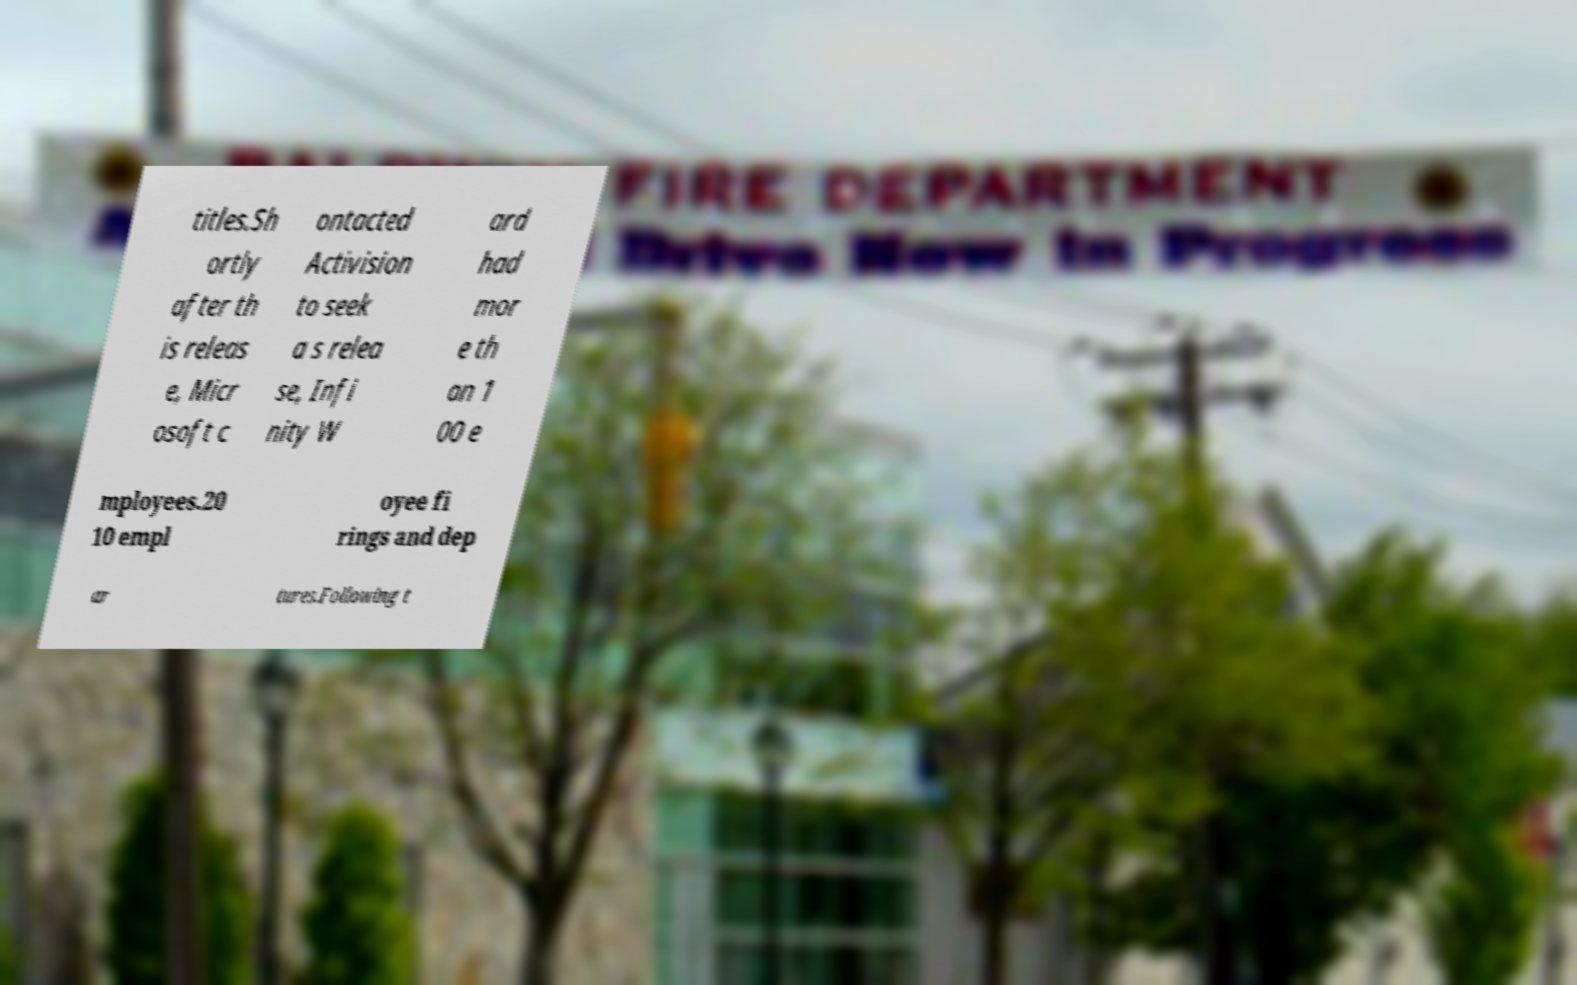Can you accurately transcribe the text from the provided image for me? titles.Sh ortly after th is releas e, Micr osoft c ontacted Activision to seek a s relea se, Infi nity W ard had mor e th an 1 00 e mployees.20 10 empl oyee fi rings and dep ar tures.Following t 